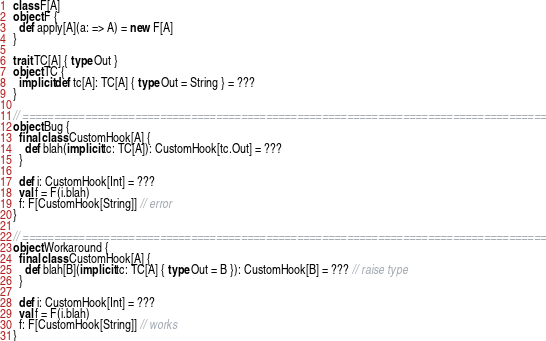Convert code to text. <code><loc_0><loc_0><loc_500><loc_500><_Scala_>class F[A]
object F {
  def apply[A](a: => A) = new F[A]
}

trait TC[A] { type Out }
object TC {
  implicit def tc[A]: TC[A] { type Out = String } = ???
}

// ====================================================================================
object Bug {
  final class CustomHook[A] {
    def blah(implicit tc: TC[A]): CustomHook[tc.Out] = ???
  }

  def i: CustomHook[Int] = ???
  val f = F(i.blah)
  f: F[CustomHook[String]] // error
}

// ====================================================================================
object Workaround {
  final class CustomHook[A] {
    def blah[B](implicit tc: TC[A] { type Out = B }): CustomHook[B] = ??? // raise type
  }

  def i: CustomHook[Int] = ???
  val f = F(i.blah)
  f: F[CustomHook[String]] // works
}</code> 